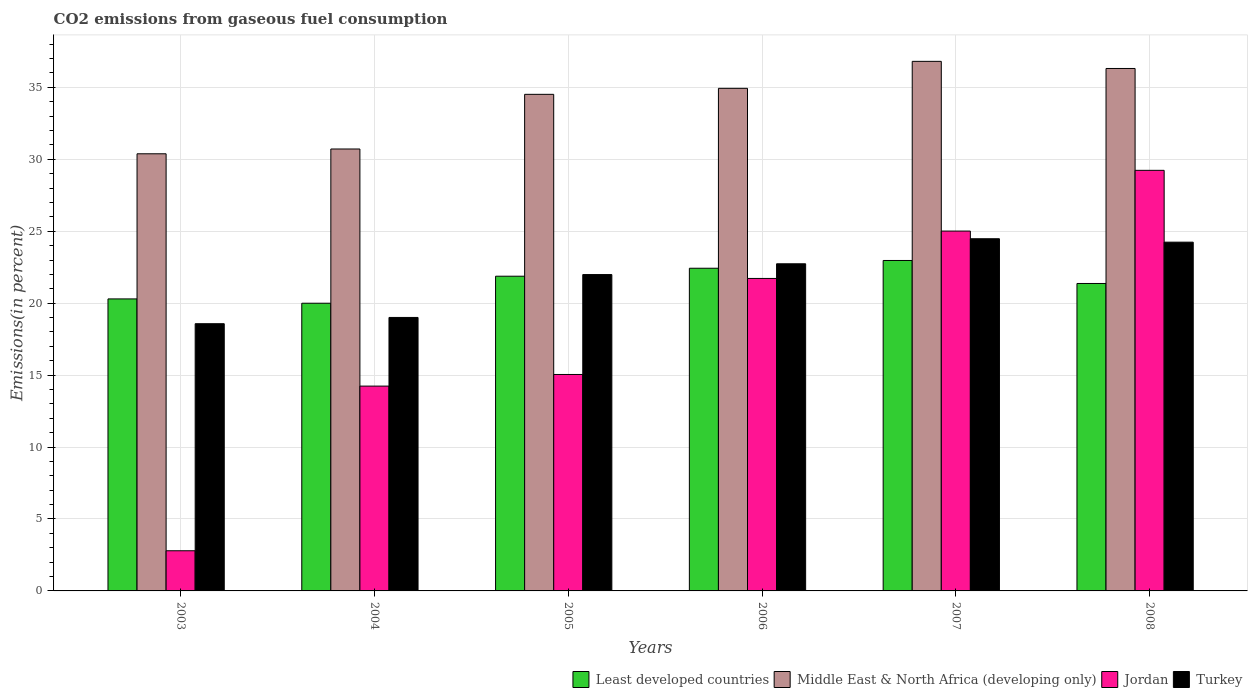Are the number of bars per tick equal to the number of legend labels?
Make the answer very short. Yes. Are the number of bars on each tick of the X-axis equal?
Offer a very short reply. Yes. How many bars are there on the 2nd tick from the right?
Ensure brevity in your answer.  4. What is the label of the 5th group of bars from the left?
Offer a very short reply. 2007. In how many cases, is the number of bars for a given year not equal to the number of legend labels?
Offer a terse response. 0. What is the total CO2 emitted in Least developed countries in 2003?
Offer a very short reply. 20.3. Across all years, what is the maximum total CO2 emitted in Jordan?
Your answer should be very brief. 29.23. Across all years, what is the minimum total CO2 emitted in Least developed countries?
Make the answer very short. 20. In which year was the total CO2 emitted in Jordan minimum?
Your response must be concise. 2003. What is the total total CO2 emitted in Middle East & North Africa (developing only) in the graph?
Ensure brevity in your answer.  203.67. What is the difference between the total CO2 emitted in Least developed countries in 2006 and that in 2008?
Your answer should be compact. 1.06. What is the difference between the total CO2 emitted in Least developed countries in 2008 and the total CO2 emitted in Turkey in 2004?
Provide a short and direct response. 2.36. What is the average total CO2 emitted in Jordan per year?
Offer a terse response. 18.01. In the year 2003, what is the difference between the total CO2 emitted in Jordan and total CO2 emitted in Least developed countries?
Provide a succinct answer. -17.5. In how many years, is the total CO2 emitted in Jordan greater than 13 %?
Make the answer very short. 5. What is the ratio of the total CO2 emitted in Jordan in 2003 to that in 2007?
Your response must be concise. 0.11. Is the difference between the total CO2 emitted in Jordan in 2007 and 2008 greater than the difference between the total CO2 emitted in Least developed countries in 2007 and 2008?
Provide a succinct answer. No. What is the difference between the highest and the second highest total CO2 emitted in Jordan?
Offer a terse response. 4.22. What is the difference between the highest and the lowest total CO2 emitted in Middle East & North Africa (developing only)?
Your answer should be very brief. 6.42. In how many years, is the total CO2 emitted in Jordan greater than the average total CO2 emitted in Jordan taken over all years?
Make the answer very short. 3. Is it the case that in every year, the sum of the total CO2 emitted in Middle East & North Africa (developing only) and total CO2 emitted in Jordan is greater than the sum of total CO2 emitted in Least developed countries and total CO2 emitted in Turkey?
Your answer should be very brief. No. What does the 1st bar from the left in 2004 represents?
Give a very brief answer. Least developed countries. What does the 2nd bar from the right in 2005 represents?
Give a very brief answer. Jordan. Does the graph contain grids?
Give a very brief answer. Yes. How are the legend labels stacked?
Offer a terse response. Horizontal. What is the title of the graph?
Provide a succinct answer. CO2 emissions from gaseous fuel consumption. Does "Brazil" appear as one of the legend labels in the graph?
Ensure brevity in your answer.  No. What is the label or title of the Y-axis?
Ensure brevity in your answer.  Emissions(in percent). What is the Emissions(in percent) in Least developed countries in 2003?
Give a very brief answer. 20.3. What is the Emissions(in percent) of Middle East & North Africa (developing only) in 2003?
Provide a succinct answer. 30.38. What is the Emissions(in percent) of Jordan in 2003?
Offer a very short reply. 2.79. What is the Emissions(in percent) in Turkey in 2003?
Ensure brevity in your answer.  18.57. What is the Emissions(in percent) of Least developed countries in 2004?
Offer a very short reply. 20. What is the Emissions(in percent) in Middle East & North Africa (developing only) in 2004?
Your answer should be very brief. 30.72. What is the Emissions(in percent) of Jordan in 2004?
Provide a short and direct response. 14.24. What is the Emissions(in percent) in Turkey in 2004?
Make the answer very short. 19.01. What is the Emissions(in percent) in Least developed countries in 2005?
Provide a succinct answer. 21.87. What is the Emissions(in percent) in Middle East & North Africa (developing only) in 2005?
Offer a very short reply. 34.52. What is the Emissions(in percent) of Jordan in 2005?
Your answer should be compact. 15.04. What is the Emissions(in percent) of Turkey in 2005?
Provide a short and direct response. 21.99. What is the Emissions(in percent) of Least developed countries in 2006?
Give a very brief answer. 22.43. What is the Emissions(in percent) in Middle East & North Africa (developing only) in 2006?
Provide a succinct answer. 34.93. What is the Emissions(in percent) of Jordan in 2006?
Provide a succinct answer. 21.72. What is the Emissions(in percent) of Turkey in 2006?
Make the answer very short. 22.74. What is the Emissions(in percent) of Least developed countries in 2007?
Offer a very short reply. 22.97. What is the Emissions(in percent) in Middle East & North Africa (developing only) in 2007?
Offer a terse response. 36.81. What is the Emissions(in percent) of Jordan in 2007?
Give a very brief answer. 25.01. What is the Emissions(in percent) in Turkey in 2007?
Provide a succinct answer. 24.48. What is the Emissions(in percent) in Least developed countries in 2008?
Give a very brief answer. 21.37. What is the Emissions(in percent) of Middle East & North Africa (developing only) in 2008?
Offer a terse response. 36.31. What is the Emissions(in percent) in Jordan in 2008?
Your answer should be very brief. 29.23. What is the Emissions(in percent) in Turkey in 2008?
Keep it short and to the point. 24.24. Across all years, what is the maximum Emissions(in percent) of Least developed countries?
Your answer should be very brief. 22.97. Across all years, what is the maximum Emissions(in percent) in Middle East & North Africa (developing only)?
Provide a succinct answer. 36.81. Across all years, what is the maximum Emissions(in percent) of Jordan?
Your response must be concise. 29.23. Across all years, what is the maximum Emissions(in percent) in Turkey?
Keep it short and to the point. 24.48. Across all years, what is the minimum Emissions(in percent) in Least developed countries?
Your response must be concise. 20. Across all years, what is the minimum Emissions(in percent) of Middle East & North Africa (developing only)?
Give a very brief answer. 30.38. Across all years, what is the minimum Emissions(in percent) of Jordan?
Offer a terse response. 2.79. Across all years, what is the minimum Emissions(in percent) of Turkey?
Your answer should be very brief. 18.57. What is the total Emissions(in percent) in Least developed countries in the graph?
Give a very brief answer. 128.93. What is the total Emissions(in percent) in Middle East & North Africa (developing only) in the graph?
Offer a very short reply. 203.67. What is the total Emissions(in percent) of Jordan in the graph?
Your answer should be compact. 108.04. What is the total Emissions(in percent) in Turkey in the graph?
Offer a very short reply. 131.03. What is the difference between the Emissions(in percent) of Least developed countries in 2003 and that in 2004?
Give a very brief answer. 0.3. What is the difference between the Emissions(in percent) in Middle East & North Africa (developing only) in 2003 and that in 2004?
Your answer should be very brief. -0.33. What is the difference between the Emissions(in percent) in Jordan in 2003 and that in 2004?
Your answer should be compact. -11.44. What is the difference between the Emissions(in percent) of Turkey in 2003 and that in 2004?
Provide a succinct answer. -0.44. What is the difference between the Emissions(in percent) in Least developed countries in 2003 and that in 2005?
Give a very brief answer. -1.58. What is the difference between the Emissions(in percent) in Middle East & North Africa (developing only) in 2003 and that in 2005?
Provide a short and direct response. -4.13. What is the difference between the Emissions(in percent) of Jordan in 2003 and that in 2005?
Offer a terse response. -12.25. What is the difference between the Emissions(in percent) in Turkey in 2003 and that in 2005?
Provide a succinct answer. -3.42. What is the difference between the Emissions(in percent) of Least developed countries in 2003 and that in 2006?
Give a very brief answer. -2.13. What is the difference between the Emissions(in percent) of Middle East & North Africa (developing only) in 2003 and that in 2006?
Ensure brevity in your answer.  -4.55. What is the difference between the Emissions(in percent) of Jordan in 2003 and that in 2006?
Offer a terse response. -18.93. What is the difference between the Emissions(in percent) in Turkey in 2003 and that in 2006?
Make the answer very short. -4.17. What is the difference between the Emissions(in percent) of Least developed countries in 2003 and that in 2007?
Offer a terse response. -2.67. What is the difference between the Emissions(in percent) in Middle East & North Africa (developing only) in 2003 and that in 2007?
Your response must be concise. -6.42. What is the difference between the Emissions(in percent) of Jordan in 2003 and that in 2007?
Ensure brevity in your answer.  -22.22. What is the difference between the Emissions(in percent) of Turkey in 2003 and that in 2007?
Keep it short and to the point. -5.91. What is the difference between the Emissions(in percent) of Least developed countries in 2003 and that in 2008?
Your response must be concise. -1.07. What is the difference between the Emissions(in percent) in Middle East & North Africa (developing only) in 2003 and that in 2008?
Your answer should be very brief. -5.93. What is the difference between the Emissions(in percent) in Jordan in 2003 and that in 2008?
Offer a terse response. -26.44. What is the difference between the Emissions(in percent) of Turkey in 2003 and that in 2008?
Offer a terse response. -5.67. What is the difference between the Emissions(in percent) of Least developed countries in 2004 and that in 2005?
Your response must be concise. -1.88. What is the difference between the Emissions(in percent) of Middle East & North Africa (developing only) in 2004 and that in 2005?
Your answer should be compact. -3.8. What is the difference between the Emissions(in percent) of Jordan in 2004 and that in 2005?
Your response must be concise. -0.81. What is the difference between the Emissions(in percent) of Turkey in 2004 and that in 2005?
Provide a succinct answer. -2.98. What is the difference between the Emissions(in percent) of Least developed countries in 2004 and that in 2006?
Give a very brief answer. -2.43. What is the difference between the Emissions(in percent) of Middle East & North Africa (developing only) in 2004 and that in 2006?
Ensure brevity in your answer.  -4.22. What is the difference between the Emissions(in percent) in Jordan in 2004 and that in 2006?
Your answer should be compact. -7.48. What is the difference between the Emissions(in percent) of Turkey in 2004 and that in 2006?
Provide a succinct answer. -3.73. What is the difference between the Emissions(in percent) of Least developed countries in 2004 and that in 2007?
Provide a short and direct response. -2.97. What is the difference between the Emissions(in percent) in Middle East & North Africa (developing only) in 2004 and that in 2007?
Offer a very short reply. -6.09. What is the difference between the Emissions(in percent) in Jordan in 2004 and that in 2007?
Make the answer very short. -10.78. What is the difference between the Emissions(in percent) of Turkey in 2004 and that in 2007?
Keep it short and to the point. -5.47. What is the difference between the Emissions(in percent) of Least developed countries in 2004 and that in 2008?
Give a very brief answer. -1.37. What is the difference between the Emissions(in percent) of Middle East & North Africa (developing only) in 2004 and that in 2008?
Your response must be concise. -5.6. What is the difference between the Emissions(in percent) of Jordan in 2004 and that in 2008?
Ensure brevity in your answer.  -15. What is the difference between the Emissions(in percent) in Turkey in 2004 and that in 2008?
Your answer should be compact. -5.23. What is the difference between the Emissions(in percent) of Least developed countries in 2005 and that in 2006?
Give a very brief answer. -0.55. What is the difference between the Emissions(in percent) in Middle East & North Africa (developing only) in 2005 and that in 2006?
Make the answer very short. -0.42. What is the difference between the Emissions(in percent) of Jordan in 2005 and that in 2006?
Your answer should be compact. -6.67. What is the difference between the Emissions(in percent) of Turkey in 2005 and that in 2006?
Offer a very short reply. -0.75. What is the difference between the Emissions(in percent) of Least developed countries in 2005 and that in 2007?
Offer a terse response. -1.09. What is the difference between the Emissions(in percent) in Middle East & North Africa (developing only) in 2005 and that in 2007?
Keep it short and to the point. -2.29. What is the difference between the Emissions(in percent) of Jordan in 2005 and that in 2007?
Offer a very short reply. -9.97. What is the difference between the Emissions(in percent) of Turkey in 2005 and that in 2007?
Your answer should be compact. -2.49. What is the difference between the Emissions(in percent) in Least developed countries in 2005 and that in 2008?
Provide a short and direct response. 0.5. What is the difference between the Emissions(in percent) of Middle East & North Africa (developing only) in 2005 and that in 2008?
Your answer should be very brief. -1.8. What is the difference between the Emissions(in percent) of Jordan in 2005 and that in 2008?
Provide a short and direct response. -14.19. What is the difference between the Emissions(in percent) of Turkey in 2005 and that in 2008?
Make the answer very short. -2.25. What is the difference between the Emissions(in percent) in Least developed countries in 2006 and that in 2007?
Your answer should be compact. -0.54. What is the difference between the Emissions(in percent) in Middle East & North Africa (developing only) in 2006 and that in 2007?
Your response must be concise. -1.88. What is the difference between the Emissions(in percent) in Jordan in 2006 and that in 2007?
Keep it short and to the point. -3.29. What is the difference between the Emissions(in percent) of Turkey in 2006 and that in 2007?
Ensure brevity in your answer.  -1.74. What is the difference between the Emissions(in percent) of Least developed countries in 2006 and that in 2008?
Provide a short and direct response. 1.06. What is the difference between the Emissions(in percent) in Middle East & North Africa (developing only) in 2006 and that in 2008?
Make the answer very short. -1.38. What is the difference between the Emissions(in percent) of Jordan in 2006 and that in 2008?
Your answer should be compact. -7.52. What is the difference between the Emissions(in percent) in Turkey in 2006 and that in 2008?
Your answer should be compact. -1.5. What is the difference between the Emissions(in percent) of Least developed countries in 2007 and that in 2008?
Your answer should be very brief. 1.6. What is the difference between the Emissions(in percent) in Middle East & North Africa (developing only) in 2007 and that in 2008?
Your response must be concise. 0.49. What is the difference between the Emissions(in percent) in Jordan in 2007 and that in 2008?
Ensure brevity in your answer.  -4.22. What is the difference between the Emissions(in percent) in Turkey in 2007 and that in 2008?
Your response must be concise. 0.24. What is the difference between the Emissions(in percent) of Least developed countries in 2003 and the Emissions(in percent) of Middle East & North Africa (developing only) in 2004?
Keep it short and to the point. -10.42. What is the difference between the Emissions(in percent) in Least developed countries in 2003 and the Emissions(in percent) in Jordan in 2004?
Offer a very short reply. 6.06. What is the difference between the Emissions(in percent) in Least developed countries in 2003 and the Emissions(in percent) in Turkey in 2004?
Provide a short and direct response. 1.29. What is the difference between the Emissions(in percent) of Middle East & North Africa (developing only) in 2003 and the Emissions(in percent) of Jordan in 2004?
Your answer should be very brief. 16.15. What is the difference between the Emissions(in percent) of Middle East & North Africa (developing only) in 2003 and the Emissions(in percent) of Turkey in 2004?
Make the answer very short. 11.38. What is the difference between the Emissions(in percent) of Jordan in 2003 and the Emissions(in percent) of Turkey in 2004?
Your response must be concise. -16.22. What is the difference between the Emissions(in percent) in Least developed countries in 2003 and the Emissions(in percent) in Middle East & North Africa (developing only) in 2005?
Your answer should be very brief. -14.22. What is the difference between the Emissions(in percent) in Least developed countries in 2003 and the Emissions(in percent) in Jordan in 2005?
Give a very brief answer. 5.25. What is the difference between the Emissions(in percent) of Least developed countries in 2003 and the Emissions(in percent) of Turkey in 2005?
Your response must be concise. -1.69. What is the difference between the Emissions(in percent) of Middle East & North Africa (developing only) in 2003 and the Emissions(in percent) of Jordan in 2005?
Your answer should be very brief. 15.34. What is the difference between the Emissions(in percent) in Middle East & North Africa (developing only) in 2003 and the Emissions(in percent) in Turkey in 2005?
Ensure brevity in your answer.  8.39. What is the difference between the Emissions(in percent) in Jordan in 2003 and the Emissions(in percent) in Turkey in 2005?
Ensure brevity in your answer.  -19.2. What is the difference between the Emissions(in percent) of Least developed countries in 2003 and the Emissions(in percent) of Middle East & North Africa (developing only) in 2006?
Your answer should be compact. -14.64. What is the difference between the Emissions(in percent) in Least developed countries in 2003 and the Emissions(in percent) in Jordan in 2006?
Provide a short and direct response. -1.42. What is the difference between the Emissions(in percent) in Least developed countries in 2003 and the Emissions(in percent) in Turkey in 2006?
Your response must be concise. -2.44. What is the difference between the Emissions(in percent) of Middle East & North Africa (developing only) in 2003 and the Emissions(in percent) of Jordan in 2006?
Provide a short and direct response. 8.66. What is the difference between the Emissions(in percent) of Middle East & North Africa (developing only) in 2003 and the Emissions(in percent) of Turkey in 2006?
Offer a very short reply. 7.65. What is the difference between the Emissions(in percent) of Jordan in 2003 and the Emissions(in percent) of Turkey in 2006?
Offer a very short reply. -19.95. What is the difference between the Emissions(in percent) of Least developed countries in 2003 and the Emissions(in percent) of Middle East & North Africa (developing only) in 2007?
Your response must be concise. -16.51. What is the difference between the Emissions(in percent) in Least developed countries in 2003 and the Emissions(in percent) in Jordan in 2007?
Make the answer very short. -4.72. What is the difference between the Emissions(in percent) of Least developed countries in 2003 and the Emissions(in percent) of Turkey in 2007?
Your answer should be very brief. -4.18. What is the difference between the Emissions(in percent) of Middle East & North Africa (developing only) in 2003 and the Emissions(in percent) of Jordan in 2007?
Ensure brevity in your answer.  5.37. What is the difference between the Emissions(in percent) of Middle East & North Africa (developing only) in 2003 and the Emissions(in percent) of Turkey in 2007?
Ensure brevity in your answer.  5.91. What is the difference between the Emissions(in percent) of Jordan in 2003 and the Emissions(in percent) of Turkey in 2007?
Your answer should be compact. -21.69. What is the difference between the Emissions(in percent) in Least developed countries in 2003 and the Emissions(in percent) in Middle East & North Africa (developing only) in 2008?
Make the answer very short. -16.02. What is the difference between the Emissions(in percent) in Least developed countries in 2003 and the Emissions(in percent) in Jordan in 2008?
Provide a short and direct response. -8.94. What is the difference between the Emissions(in percent) of Least developed countries in 2003 and the Emissions(in percent) of Turkey in 2008?
Make the answer very short. -3.94. What is the difference between the Emissions(in percent) of Middle East & North Africa (developing only) in 2003 and the Emissions(in percent) of Jordan in 2008?
Provide a short and direct response. 1.15. What is the difference between the Emissions(in percent) in Middle East & North Africa (developing only) in 2003 and the Emissions(in percent) in Turkey in 2008?
Offer a terse response. 6.14. What is the difference between the Emissions(in percent) in Jordan in 2003 and the Emissions(in percent) in Turkey in 2008?
Give a very brief answer. -21.45. What is the difference between the Emissions(in percent) of Least developed countries in 2004 and the Emissions(in percent) of Middle East & North Africa (developing only) in 2005?
Make the answer very short. -14.52. What is the difference between the Emissions(in percent) of Least developed countries in 2004 and the Emissions(in percent) of Jordan in 2005?
Give a very brief answer. 4.95. What is the difference between the Emissions(in percent) of Least developed countries in 2004 and the Emissions(in percent) of Turkey in 2005?
Give a very brief answer. -1.99. What is the difference between the Emissions(in percent) of Middle East & North Africa (developing only) in 2004 and the Emissions(in percent) of Jordan in 2005?
Give a very brief answer. 15.67. What is the difference between the Emissions(in percent) of Middle East & North Africa (developing only) in 2004 and the Emissions(in percent) of Turkey in 2005?
Make the answer very short. 8.73. What is the difference between the Emissions(in percent) of Jordan in 2004 and the Emissions(in percent) of Turkey in 2005?
Ensure brevity in your answer.  -7.75. What is the difference between the Emissions(in percent) in Least developed countries in 2004 and the Emissions(in percent) in Middle East & North Africa (developing only) in 2006?
Your answer should be compact. -14.94. What is the difference between the Emissions(in percent) of Least developed countries in 2004 and the Emissions(in percent) of Jordan in 2006?
Your answer should be compact. -1.72. What is the difference between the Emissions(in percent) in Least developed countries in 2004 and the Emissions(in percent) in Turkey in 2006?
Ensure brevity in your answer.  -2.74. What is the difference between the Emissions(in percent) in Middle East & North Africa (developing only) in 2004 and the Emissions(in percent) in Jordan in 2006?
Your response must be concise. 9. What is the difference between the Emissions(in percent) of Middle East & North Africa (developing only) in 2004 and the Emissions(in percent) of Turkey in 2006?
Offer a terse response. 7.98. What is the difference between the Emissions(in percent) of Jordan in 2004 and the Emissions(in percent) of Turkey in 2006?
Your answer should be very brief. -8.5. What is the difference between the Emissions(in percent) of Least developed countries in 2004 and the Emissions(in percent) of Middle East & North Africa (developing only) in 2007?
Your answer should be very brief. -16.81. What is the difference between the Emissions(in percent) of Least developed countries in 2004 and the Emissions(in percent) of Jordan in 2007?
Your answer should be compact. -5.02. What is the difference between the Emissions(in percent) in Least developed countries in 2004 and the Emissions(in percent) in Turkey in 2007?
Keep it short and to the point. -4.48. What is the difference between the Emissions(in percent) in Middle East & North Africa (developing only) in 2004 and the Emissions(in percent) in Jordan in 2007?
Your answer should be very brief. 5.7. What is the difference between the Emissions(in percent) in Middle East & North Africa (developing only) in 2004 and the Emissions(in percent) in Turkey in 2007?
Provide a succinct answer. 6.24. What is the difference between the Emissions(in percent) in Jordan in 2004 and the Emissions(in percent) in Turkey in 2007?
Your response must be concise. -10.24. What is the difference between the Emissions(in percent) of Least developed countries in 2004 and the Emissions(in percent) of Middle East & North Africa (developing only) in 2008?
Your answer should be very brief. -16.32. What is the difference between the Emissions(in percent) of Least developed countries in 2004 and the Emissions(in percent) of Jordan in 2008?
Provide a short and direct response. -9.24. What is the difference between the Emissions(in percent) in Least developed countries in 2004 and the Emissions(in percent) in Turkey in 2008?
Give a very brief answer. -4.24. What is the difference between the Emissions(in percent) of Middle East & North Africa (developing only) in 2004 and the Emissions(in percent) of Jordan in 2008?
Offer a terse response. 1.48. What is the difference between the Emissions(in percent) in Middle East & North Africa (developing only) in 2004 and the Emissions(in percent) in Turkey in 2008?
Make the answer very short. 6.48. What is the difference between the Emissions(in percent) in Jordan in 2004 and the Emissions(in percent) in Turkey in 2008?
Keep it short and to the point. -10. What is the difference between the Emissions(in percent) of Least developed countries in 2005 and the Emissions(in percent) of Middle East & North Africa (developing only) in 2006?
Your response must be concise. -13.06. What is the difference between the Emissions(in percent) of Least developed countries in 2005 and the Emissions(in percent) of Jordan in 2006?
Your answer should be compact. 0.16. What is the difference between the Emissions(in percent) of Least developed countries in 2005 and the Emissions(in percent) of Turkey in 2006?
Keep it short and to the point. -0.86. What is the difference between the Emissions(in percent) of Middle East & North Africa (developing only) in 2005 and the Emissions(in percent) of Jordan in 2006?
Your response must be concise. 12.8. What is the difference between the Emissions(in percent) in Middle East & North Africa (developing only) in 2005 and the Emissions(in percent) in Turkey in 2006?
Provide a short and direct response. 11.78. What is the difference between the Emissions(in percent) of Jordan in 2005 and the Emissions(in percent) of Turkey in 2006?
Make the answer very short. -7.69. What is the difference between the Emissions(in percent) in Least developed countries in 2005 and the Emissions(in percent) in Middle East & North Africa (developing only) in 2007?
Make the answer very short. -14.93. What is the difference between the Emissions(in percent) in Least developed countries in 2005 and the Emissions(in percent) in Jordan in 2007?
Give a very brief answer. -3.14. What is the difference between the Emissions(in percent) in Least developed countries in 2005 and the Emissions(in percent) in Turkey in 2007?
Ensure brevity in your answer.  -2.6. What is the difference between the Emissions(in percent) in Middle East & North Africa (developing only) in 2005 and the Emissions(in percent) in Jordan in 2007?
Give a very brief answer. 9.5. What is the difference between the Emissions(in percent) in Middle East & North Africa (developing only) in 2005 and the Emissions(in percent) in Turkey in 2007?
Ensure brevity in your answer.  10.04. What is the difference between the Emissions(in percent) of Jordan in 2005 and the Emissions(in percent) of Turkey in 2007?
Offer a very short reply. -9.43. What is the difference between the Emissions(in percent) of Least developed countries in 2005 and the Emissions(in percent) of Middle East & North Africa (developing only) in 2008?
Keep it short and to the point. -14.44. What is the difference between the Emissions(in percent) in Least developed countries in 2005 and the Emissions(in percent) in Jordan in 2008?
Provide a succinct answer. -7.36. What is the difference between the Emissions(in percent) in Least developed countries in 2005 and the Emissions(in percent) in Turkey in 2008?
Give a very brief answer. -2.37. What is the difference between the Emissions(in percent) of Middle East & North Africa (developing only) in 2005 and the Emissions(in percent) of Jordan in 2008?
Your response must be concise. 5.28. What is the difference between the Emissions(in percent) in Middle East & North Africa (developing only) in 2005 and the Emissions(in percent) in Turkey in 2008?
Give a very brief answer. 10.28. What is the difference between the Emissions(in percent) in Jordan in 2005 and the Emissions(in percent) in Turkey in 2008?
Your answer should be compact. -9.2. What is the difference between the Emissions(in percent) of Least developed countries in 2006 and the Emissions(in percent) of Middle East & North Africa (developing only) in 2007?
Offer a very short reply. -14.38. What is the difference between the Emissions(in percent) of Least developed countries in 2006 and the Emissions(in percent) of Jordan in 2007?
Your response must be concise. -2.58. What is the difference between the Emissions(in percent) in Least developed countries in 2006 and the Emissions(in percent) in Turkey in 2007?
Give a very brief answer. -2.05. What is the difference between the Emissions(in percent) in Middle East & North Africa (developing only) in 2006 and the Emissions(in percent) in Jordan in 2007?
Your answer should be very brief. 9.92. What is the difference between the Emissions(in percent) in Middle East & North Africa (developing only) in 2006 and the Emissions(in percent) in Turkey in 2007?
Provide a succinct answer. 10.45. What is the difference between the Emissions(in percent) of Jordan in 2006 and the Emissions(in percent) of Turkey in 2007?
Make the answer very short. -2.76. What is the difference between the Emissions(in percent) in Least developed countries in 2006 and the Emissions(in percent) in Middle East & North Africa (developing only) in 2008?
Provide a short and direct response. -13.89. What is the difference between the Emissions(in percent) of Least developed countries in 2006 and the Emissions(in percent) of Jordan in 2008?
Your response must be concise. -6.81. What is the difference between the Emissions(in percent) of Least developed countries in 2006 and the Emissions(in percent) of Turkey in 2008?
Provide a short and direct response. -1.81. What is the difference between the Emissions(in percent) of Middle East & North Africa (developing only) in 2006 and the Emissions(in percent) of Jordan in 2008?
Make the answer very short. 5.7. What is the difference between the Emissions(in percent) in Middle East & North Africa (developing only) in 2006 and the Emissions(in percent) in Turkey in 2008?
Offer a very short reply. 10.69. What is the difference between the Emissions(in percent) in Jordan in 2006 and the Emissions(in percent) in Turkey in 2008?
Your answer should be very brief. -2.52. What is the difference between the Emissions(in percent) in Least developed countries in 2007 and the Emissions(in percent) in Middle East & North Africa (developing only) in 2008?
Provide a short and direct response. -13.35. What is the difference between the Emissions(in percent) of Least developed countries in 2007 and the Emissions(in percent) of Jordan in 2008?
Offer a very short reply. -6.27. What is the difference between the Emissions(in percent) in Least developed countries in 2007 and the Emissions(in percent) in Turkey in 2008?
Offer a very short reply. -1.27. What is the difference between the Emissions(in percent) of Middle East & North Africa (developing only) in 2007 and the Emissions(in percent) of Jordan in 2008?
Your response must be concise. 7.57. What is the difference between the Emissions(in percent) in Middle East & North Africa (developing only) in 2007 and the Emissions(in percent) in Turkey in 2008?
Provide a short and direct response. 12.57. What is the difference between the Emissions(in percent) in Jordan in 2007 and the Emissions(in percent) in Turkey in 2008?
Make the answer very short. 0.77. What is the average Emissions(in percent) of Least developed countries per year?
Your response must be concise. 21.49. What is the average Emissions(in percent) of Middle East & North Africa (developing only) per year?
Make the answer very short. 33.95. What is the average Emissions(in percent) in Jordan per year?
Offer a very short reply. 18.01. What is the average Emissions(in percent) in Turkey per year?
Keep it short and to the point. 21.84. In the year 2003, what is the difference between the Emissions(in percent) in Least developed countries and Emissions(in percent) in Middle East & North Africa (developing only)?
Provide a succinct answer. -10.09. In the year 2003, what is the difference between the Emissions(in percent) in Least developed countries and Emissions(in percent) in Jordan?
Give a very brief answer. 17.5. In the year 2003, what is the difference between the Emissions(in percent) in Least developed countries and Emissions(in percent) in Turkey?
Your answer should be very brief. 1.72. In the year 2003, what is the difference between the Emissions(in percent) in Middle East & North Africa (developing only) and Emissions(in percent) in Jordan?
Offer a very short reply. 27.59. In the year 2003, what is the difference between the Emissions(in percent) in Middle East & North Africa (developing only) and Emissions(in percent) in Turkey?
Your answer should be compact. 11.81. In the year 2003, what is the difference between the Emissions(in percent) in Jordan and Emissions(in percent) in Turkey?
Ensure brevity in your answer.  -15.78. In the year 2004, what is the difference between the Emissions(in percent) of Least developed countries and Emissions(in percent) of Middle East & North Africa (developing only)?
Offer a terse response. -10.72. In the year 2004, what is the difference between the Emissions(in percent) in Least developed countries and Emissions(in percent) in Jordan?
Offer a terse response. 5.76. In the year 2004, what is the difference between the Emissions(in percent) of Least developed countries and Emissions(in percent) of Turkey?
Provide a succinct answer. 0.99. In the year 2004, what is the difference between the Emissions(in percent) of Middle East & North Africa (developing only) and Emissions(in percent) of Jordan?
Offer a very short reply. 16.48. In the year 2004, what is the difference between the Emissions(in percent) in Middle East & North Africa (developing only) and Emissions(in percent) in Turkey?
Keep it short and to the point. 11.71. In the year 2004, what is the difference between the Emissions(in percent) of Jordan and Emissions(in percent) of Turkey?
Offer a terse response. -4.77. In the year 2005, what is the difference between the Emissions(in percent) in Least developed countries and Emissions(in percent) in Middle East & North Africa (developing only)?
Provide a succinct answer. -12.64. In the year 2005, what is the difference between the Emissions(in percent) of Least developed countries and Emissions(in percent) of Jordan?
Provide a short and direct response. 6.83. In the year 2005, what is the difference between the Emissions(in percent) of Least developed countries and Emissions(in percent) of Turkey?
Ensure brevity in your answer.  -0.12. In the year 2005, what is the difference between the Emissions(in percent) in Middle East & North Africa (developing only) and Emissions(in percent) in Jordan?
Make the answer very short. 19.47. In the year 2005, what is the difference between the Emissions(in percent) of Middle East & North Africa (developing only) and Emissions(in percent) of Turkey?
Keep it short and to the point. 12.53. In the year 2005, what is the difference between the Emissions(in percent) in Jordan and Emissions(in percent) in Turkey?
Offer a very short reply. -6.94. In the year 2006, what is the difference between the Emissions(in percent) of Least developed countries and Emissions(in percent) of Middle East & North Africa (developing only)?
Your response must be concise. -12.5. In the year 2006, what is the difference between the Emissions(in percent) of Least developed countries and Emissions(in percent) of Jordan?
Make the answer very short. 0.71. In the year 2006, what is the difference between the Emissions(in percent) in Least developed countries and Emissions(in percent) in Turkey?
Offer a terse response. -0.31. In the year 2006, what is the difference between the Emissions(in percent) of Middle East & North Africa (developing only) and Emissions(in percent) of Jordan?
Provide a short and direct response. 13.21. In the year 2006, what is the difference between the Emissions(in percent) of Middle East & North Africa (developing only) and Emissions(in percent) of Turkey?
Offer a terse response. 12.19. In the year 2006, what is the difference between the Emissions(in percent) in Jordan and Emissions(in percent) in Turkey?
Your answer should be very brief. -1.02. In the year 2007, what is the difference between the Emissions(in percent) in Least developed countries and Emissions(in percent) in Middle East & North Africa (developing only)?
Your answer should be compact. -13.84. In the year 2007, what is the difference between the Emissions(in percent) in Least developed countries and Emissions(in percent) in Jordan?
Ensure brevity in your answer.  -2.04. In the year 2007, what is the difference between the Emissions(in percent) in Least developed countries and Emissions(in percent) in Turkey?
Your answer should be compact. -1.51. In the year 2007, what is the difference between the Emissions(in percent) in Middle East & North Africa (developing only) and Emissions(in percent) in Jordan?
Keep it short and to the point. 11.8. In the year 2007, what is the difference between the Emissions(in percent) of Middle East & North Africa (developing only) and Emissions(in percent) of Turkey?
Provide a short and direct response. 12.33. In the year 2007, what is the difference between the Emissions(in percent) of Jordan and Emissions(in percent) of Turkey?
Provide a succinct answer. 0.53. In the year 2008, what is the difference between the Emissions(in percent) in Least developed countries and Emissions(in percent) in Middle East & North Africa (developing only)?
Your answer should be compact. -14.94. In the year 2008, what is the difference between the Emissions(in percent) in Least developed countries and Emissions(in percent) in Jordan?
Your answer should be very brief. -7.86. In the year 2008, what is the difference between the Emissions(in percent) of Least developed countries and Emissions(in percent) of Turkey?
Ensure brevity in your answer.  -2.87. In the year 2008, what is the difference between the Emissions(in percent) in Middle East & North Africa (developing only) and Emissions(in percent) in Jordan?
Offer a very short reply. 7.08. In the year 2008, what is the difference between the Emissions(in percent) of Middle East & North Africa (developing only) and Emissions(in percent) of Turkey?
Offer a very short reply. 12.07. In the year 2008, what is the difference between the Emissions(in percent) in Jordan and Emissions(in percent) in Turkey?
Give a very brief answer. 4.99. What is the ratio of the Emissions(in percent) in Least developed countries in 2003 to that in 2004?
Offer a very short reply. 1.01. What is the ratio of the Emissions(in percent) in Middle East & North Africa (developing only) in 2003 to that in 2004?
Offer a very short reply. 0.99. What is the ratio of the Emissions(in percent) of Jordan in 2003 to that in 2004?
Your response must be concise. 0.2. What is the ratio of the Emissions(in percent) in Turkey in 2003 to that in 2004?
Give a very brief answer. 0.98. What is the ratio of the Emissions(in percent) of Least developed countries in 2003 to that in 2005?
Your response must be concise. 0.93. What is the ratio of the Emissions(in percent) of Middle East & North Africa (developing only) in 2003 to that in 2005?
Make the answer very short. 0.88. What is the ratio of the Emissions(in percent) in Jordan in 2003 to that in 2005?
Give a very brief answer. 0.19. What is the ratio of the Emissions(in percent) in Turkey in 2003 to that in 2005?
Give a very brief answer. 0.84. What is the ratio of the Emissions(in percent) in Least developed countries in 2003 to that in 2006?
Your answer should be compact. 0.9. What is the ratio of the Emissions(in percent) in Middle East & North Africa (developing only) in 2003 to that in 2006?
Your response must be concise. 0.87. What is the ratio of the Emissions(in percent) in Jordan in 2003 to that in 2006?
Keep it short and to the point. 0.13. What is the ratio of the Emissions(in percent) of Turkey in 2003 to that in 2006?
Give a very brief answer. 0.82. What is the ratio of the Emissions(in percent) of Least developed countries in 2003 to that in 2007?
Make the answer very short. 0.88. What is the ratio of the Emissions(in percent) of Middle East & North Africa (developing only) in 2003 to that in 2007?
Keep it short and to the point. 0.83. What is the ratio of the Emissions(in percent) of Jordan in 2003 to that in 2007?
Give a very brief answer. 0.11. What is the ratio of the Emissions(in percent) in Turkey in 2003 to that in 2007?
Keep it short and to the point. 0.76. What is the ratio of the Emissions(in percent) of Least developed countries in 2003 to that in 2008?
Ensure brevity in your answer.  0.95. What is the ratio of the Emissions(in percent) in Middle East & North Africa (developing only) in 2003 to that in 2008?
Your answer should be very brief. 0.84. What is the ratio of the Emissions(in percent) of Jordan in 2003 to that in 2008?
Your answer should be very brief. 0.1. What is the ratio of the Emissions(in percent) of Turkey in 2003 to that in 2008?
Your response must be concise. 0.77. What is the ratio of the Emissions(in percent) of Least developed countries in 2004 to that in 2005?
Your response must be concise. 0.91. What is the ratio of the Emissions(in percent) in Middle East & North Africa (developing only) in 2004 to that in 2005?
Offer a terse response. 0.89. What is the ratio of the Emissions(in percent) in Jordan in 2004 to that in 2005?
Provide a succinct answer. 0.95. What is the ratio of the Emissions(in percent) in Turkey in 2004 to that in 2005?
Give a very brief answer. 0.86. What is the ratio of the Emissions(in percent) of Least developed countries in 2004 to that in 2006?
Keep it short and to the point. 0.89. What is the ratio of the Emissions(in percent) of Middle East & North Africa (developing only) in 2004 to that in 2006?
Offer a very short reply. 0.88. What is the ratio of the Emissions(in percent) in Jordan in 2004 to that in 2006?
Give a very brief answer. 0.66. What is the ratio of the Emissions(in percent) in Turkey in 2004 to that in 2006?
Make the answer very short. 0.84. What is the ratio of the Emissions(in percent) of Least developed countries in 2004 to that in 2007?
Offer a very short reply. 0.87. What is the ratio of the Emissions(in percent) in Middle East & North Africa (developing only) in 2004 to that in 2007?
Offer a very short reply. 0.83. What is the ratio of the Emissions(in percent) in Jordan in 2004 to that in 2007?
Make the answer very short. 0.57. What is the ratio of the Emissions(in percent) of Turkey in 2004 to that in 2007?
Your answer should be very brief. 0.78. What is the ratio of the Emissions(in percent) in Least developed countries in 2004 to that in 2008?
Provide a short and direct response. 0.94. What is the ratio of the Emissions(in percent) of Middle East & North Africa (developing only) in 2004 to that in 2008?
Make the answer very short. 0.85. What is the ratio of the Emissions(in percent) in Jordan in 2004 to that in 2008?
Your response must be concise. 0.49. What is the ratio of the Emissions(in percent) in Turkey in 2004 to that in 2008?
Give a very brief answer. 0.78. What is the ratio of the Emissions(in percent) in Least developed countries in 2005 to that in 2006?
Offer a terse response. 0.98. What is the ratio of the Emissions(in percent) in Jordan in 2005 to that in 2006?
Offer a terse response. 0.69. What is the ratio of the Emissions(in percent) in Turkey in 2005 to that in 2006?
Offer a terse response. 0.97. What is the ratio of the Emissions(in percent) in Least developed countries in 2005 to that in 2007?
Provide a succinct answer. 0.95. What is the ratio of the Emissions(in percent) of Middle East & North Africa (developing only) in 2005 to that in 2007?
Offer a terse response. 0.94. What is the ratio of the Emissions(in percent) of Jordan in 2005 to that in 2007?
Offer a terse response. 0.6. What is the ratio of the Emissions(in percent) of Turkey in 2005 to that in 2007?
Provide a short and direct response. 0.9. What is the ratio of the Emissions(in percent) in Least developed countries in 2005 to that in 2008?
Provide a succinct answer. 1.02. What is the ratio of the Emissions(in percent) in Middle East & North Africa (developing only) in 2005 to that in 2008?
Your response must be concise. 0.95. What is the ratio of the Emissions(in percent) in Jordan in 2005 to that in 2008?
Make the answer very short. 0.51. What is the ratio of the Emissions(in percent) in Turkey in 2005 to that in 2008?
Ensure brevity in your answer.  0.91. What is the ratio of the Emissions(in percent) of Least developed countries in 2006 to that in 2007?
Offer a very short reply. 0.98. What is the ratio of the Emissions(in percent) in Middle East & North Africa (developing only) in 2006 to that in 2007?
Make the answer very short. 0.95. What is the ratio of the Emissions(in percent) in Jordan in 2006 to that in 2007?
Your response must be concise. 0.87. What is the ratio of the Emissions(in percent) of Turkey in 2006 to that in 2007?
Offer a very short reply. 0.93. What is the ratio of the Emissions(in percent) in Least developed countries in 2006 to that in 2008?
Provide a short and direct response. 1.05. What is the ratio of the Emissions(in percent) of Jordan in 2006 to that in 2008?
Keep it short and to the point. 0.74. What is the ratio of the Emissions(in percent) of Turkey in 2006 to that in 2008?
Offer a very short reply. 0.94. What is the ratio of the Emissions(in percent) in Least developed countries in 2007 to that in 2008?
Provide a succinct answer. 1.07. What is the ratio of the Emissions(in percent) in Middle East & North Africa (developing only) in 2007 to that in 2008?
Provide a short and direct response. 1.01. What is the ratio of the Emissions(in percent) in Jordan in 2007 to that in 2008?
Ensure brevity in your answer.  0.86. What is the ratio of the Emissions(in percent) of Turkey in 2007 to that in 2008?
Offer a very short reply. 1.01. What is the difference between the highest and the second highest Emissions(in percent) of Least developed countries?
Give a very brief answer. 0.54. What is the difference between the highest and the second highest Emissions(in percent) in Middle East & North Africa (developing only)?
Your response must be concise. 0.49. What is the difference between the highest and the second highest Emissions(in percent) in Jordan?
Your answer should be compact. 4.22. What is the difference between the highest and the second highest Emissions(in percent) in Turkey?
Keep it short and to the point. 0.24. What is the difference between the highest and the lowest Emissions(in percent) of Least developed countries?
Your answer should be compact. 2.97. What is the difference between the highest and the lowest Emissions(in percent) of Middle East & North Africa (developing only)?
Make the answer very short. 6.42. What is the difference between the highest and the lowest Emissions(in percent) in Jordan?
Provide a short and direct response. 26.44. What is the difference between the highest and the lowest Emissions(in percent) in Turkey?
Offer a terse response. 5.91. 